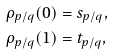<formula> <loc_0><loc_0><loc_500><loc_500>\rho _ { p / q } ( 0 ) & = s _ { p / q } , \\ \rho _ { p / q } ( 1 ) & = t _ { p / q } ,</formula> 